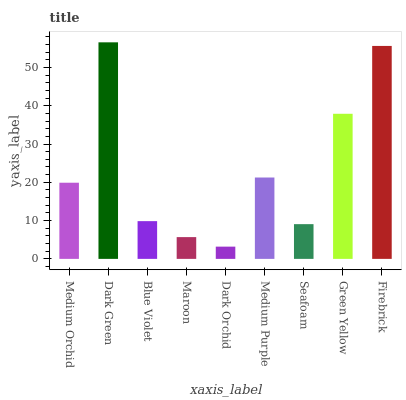Is Dark Orchid the minimum?
Answer yes or no. Yes. Is Dark Green the maximum?
Answer yes or no. Yes. Is Blue Violet the minimum?
Answer yes or no. No. Is Blue Violet the maximum?
Answer yes or no. No. Is Dark Green greater than Blue Violet?
Answer yes or no. Yes. Is Blue Violet less than Dark Green?
Answer yes or no. Yes. Is Blue Violet greater than Dark Green?
Answer yes or no. No. Is Dark Green less than Blue Violet?
Answer yes or no. No. Is Medium Orchid the high median?
Answer yes or no. Yes. Is Medium Orchid the low median?
Answer yes or no. Yes. Is Dark Orchid the high median?
Answer yes or no. No. Is Dark Green the low median?
Answer yes or no. No. 